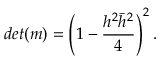<formula> <loc_0><loc_0><loc_500><loc_500>d e t ( m ) = \left ( 1 - { \frac { h ^ { 2 } \bar { h } ^ { 2 } } { 4 } } \right ) ^ { 2 } .</formula> 